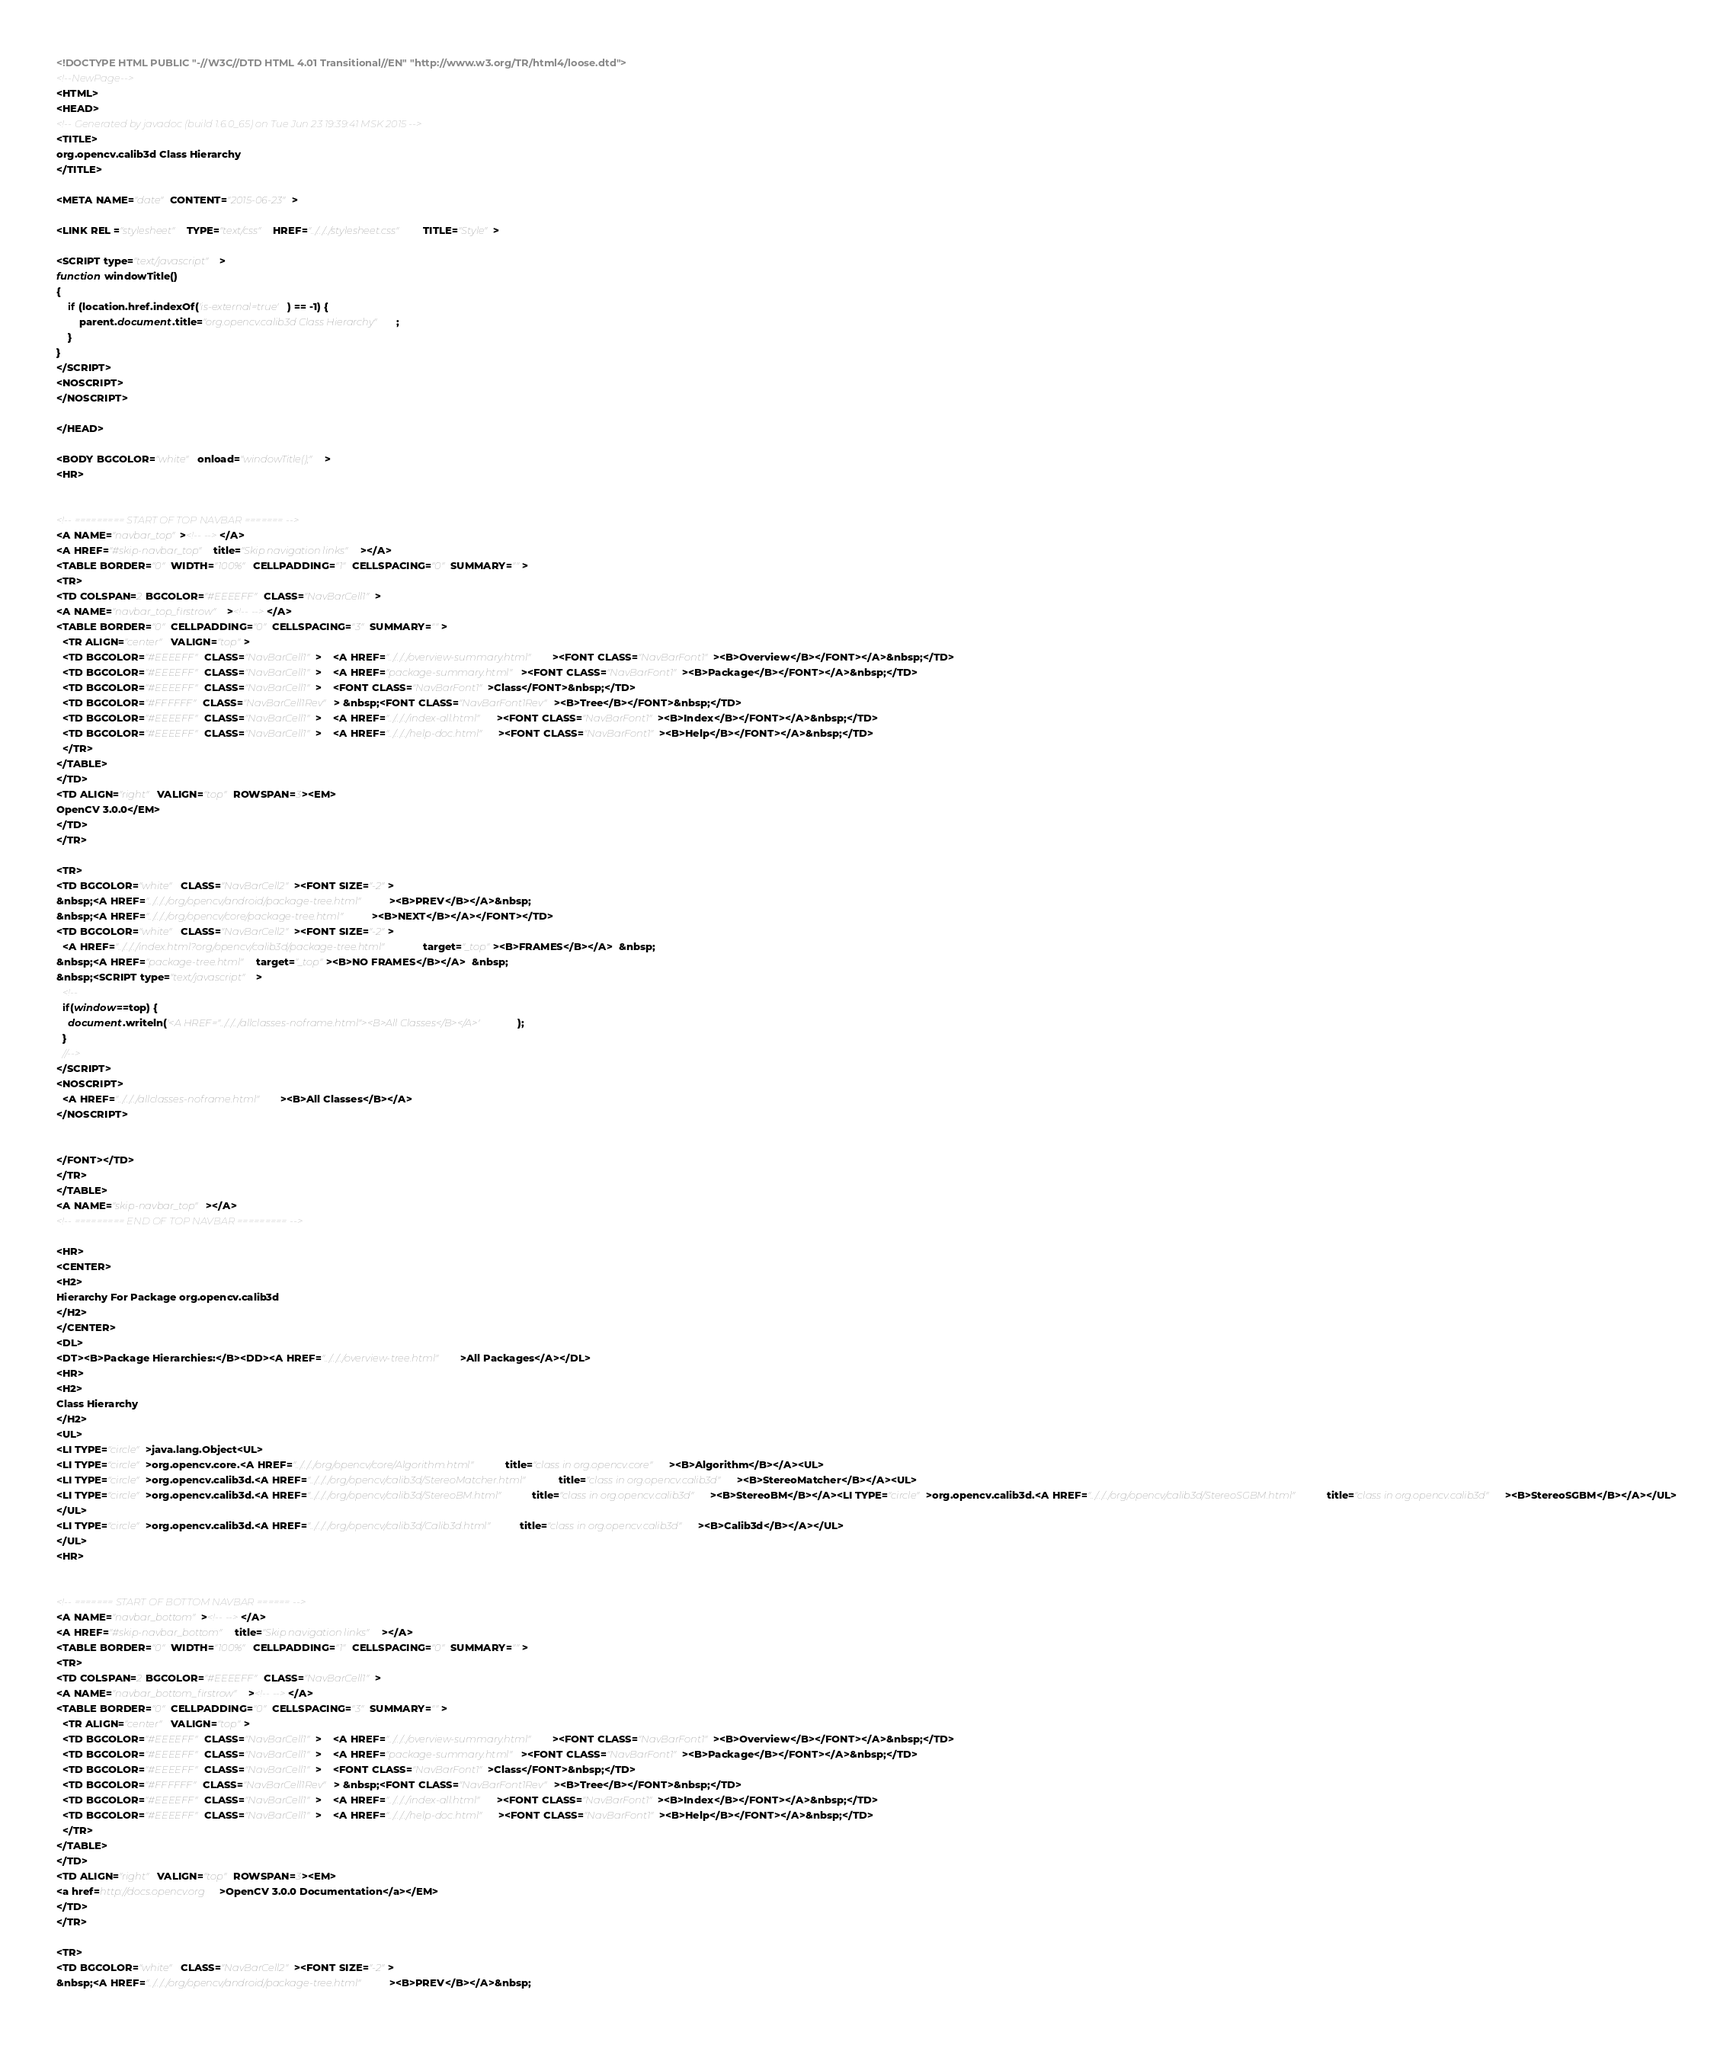Convert code to text. <code><loc_0><loc_0><loc_500><loc_500><_HTML_><!DOCTYPE HTML PUBLIC "-//W3C//DTD HTML 4.01 Transitional//EN" "http://www.w3.org/TR/html4/loose.dtd">
<!--NewPage-->
<HTML>
<HEAD>
<!-- Generated by javadoc (build 1.6.0_65) on Tue Jun 23 19:39:41 MSK 2015 -->
<TITLE>
org.opencv.calib3d Class Hierarchy
</TITLE>

<META NAME="date" CONTENT="2015-06-23">

<LINK REL ="stylesheet" TYPE="text/css" HREF="../../../stylesheet.css" TITLE="Style">

<SCRIPT type="text/javascript">
function windowTitle()
{
    if (location.href.indexOf('is-external=true') == -1) {
        parent.document.title="org.opencv.calib3d Class Hierarchy";
    }
}
</SCRIPT>
<NOSCRIPT>
</NOSCRIPT>

</HEAD>

<BODY BGCOLOR="white" onload="windowTitle();">
<HR>


<!-- ========= START OF TOP NAVBAR ======= -->
<A NAME="navbar_top"><!-- --></A>
<A HREF="#skip-navbar_top" title="Skip navigation links"></A>
<TABLE BORDER="0" WIDTH="100%" CELLPADDING="1" CELLSPACING="0" SUMMARY="">
<TR>
<TD COLSPAN=2 BGCOLOR="#EEEEFF" CLASS="NavBarCell1">
<A NAME="navbar_top_firstrow"><!-- --></A>
<TABLE BORDER="0" CELLPADDING="0" CELLSPACING="3" SUMMARY="">
  <TR ALIGN="center" VALIGN="top">
  <TD BGCOLOR="#EEEEFF" CLASS="NavBarCell1">    <A HREF="../../../overview-summary.html"><FONT CLASS="NavBarFont1"><B>Overview</B></FONT></A>&nbsp;</TD>
  <TD BGCOLOR="#EEEEFF" CLASS="NavBarCell1">    <A HREF="package-summary.html"><FONT CLASS="NavBarFont1"><B>Package</B></FONT></A>&nbsp;</TD>
  <TD BGCOLOR="#EEEEFF" CLASS="NavBarCell1">    <FONT CLASS="NavBarFont1">Class</FONT>&nbsp;</TD>
  <TD BGCOLOR="#FFFFFF" CLASS="NavBarCell1Rev"> &nbsp;<FONT CLASS="NavBarFont1Rev"><B>Tree</B></FONT>&nbsp;</TD>
  <TD BGCOLOR="#EEEEFF" CLASS="NavBarCell1">    <A HREF="../../../index-all.html"><FONT CLASS="NavBarFont1"><B>Index</B></FONT></A>&nbsp;</TD>
  <TD BGCOLOR="#EEEEFF" CLASS="NavBarCell1">    <A HREF="../../../help-doc.html"><FONT CLASS="NavBarFont1"><B>Help</B></FONT></A>&nbsp;</TD>
  </TR>
</TABLE>
</TD>
<TD ALIGN="right" VALIGN="top" ROWSPAN=3><EM>
OpenCV 3.0.0</EM>
</TD>
</TR>

<TR>
<TD BGCOLOR="white" CLASS="NavBarCell2"><FONT SIZE="-2">
&nbsp;<A HREF="../../../org/opencv/android/package-tree.html"><B>PREV</B></A>&nbsp;
&nbsp;<A HREF="../../../org/opencv/core/package-tree.html"><B>NEXT</B></A></FONT></TD>
<TD BGCOLOR="white" CLASS="NavBarCell2"><FONT SIZE="-2">
  <A HREF="../../../index.html?org/opencv/calib3d/package-tree.html" target="_top"><B>FRAMES</B></A>  &nbsp;
&nbsp;<A HREF="package-tree.html" target="_top"><B>NO FRAMES</B></A>  &nbsp;
&nbsp;<SCRIPT type="text/javascript">
  <!--
  if(window==top) {
    document.writeln('<A HREF="../../../allclasses-noframe.html"><B>All Classes</B></A>');
  }
  //-->
</SCRIPT>
<NOSCRIPT>
  <A HREF="../../../allclasses-noframe.html"><B>All Classes</B></A>
</NOSCRIPT>


</FONT></TD>
</TR>
</TABLE>
<A NAME="skip-navbar_top"></A>
<!-- ========= END OF TOP NAVBAR ========= -->

<HR>
<CENTER>
<H2>
Hierarchy For Package org.opencv.calib3d
</H2>
</CENTER>
<DL>
<DT><B>Package Hierarchies:</B><DD><A HREF="../../../overview-tree.html">All Packages</A></DL>
<HR>
<H2>
Class Hierarchy
</H2>
<UL>
<LI TYPE="circle">java.lang.Object<UL>
<LI TYPE="circle">org.opencv.core.<A HREF="../../../org/opencv/core/Algorithm.html" title="class in org.opencv.core"><B>Algorithm</B></A><UL>
<LI TYPE="circle">org.opencv.calib3d.<A HREF="../../../org/opencv/calib3d/StereoMatcher.html" title="class in org.opencv.calib3d"><B>StereoMatcher</B></A><UL>
<LI TYPE="circle">org.opencv.calib3d.<A HREF="../../../org/opencv/calib3d/StereoBM.html" title="class in org.opencv.calib3d"><B>StereoBM</B></A><LI TYPE="circle">org.opencv.calib3d.<A HREF="../../../org/opencv/calib3d/StereoSGBM.html" title="class in org.opencv.calib3d"><B>StereoSGBM</B></A></UL>
</UL>
<LI TYPE="circle">org.opencv.calib3d.<A HREF="../../../org/opencv/calib3d/Calib3d.html" title="class in org.opencv.calib3d"><B>Calib3d</B></A></UL>
</UL>
<HR>


<!-- ======= START OF BOTTOM NAVBAR ====== -->
<A NAME="navbar_bottom"><!-- --></A>
<A HREF="#skip-navbar_bottom" title="Skip navigation links"></A>
<TABLE BORDER="0" WIDTH="100%" CELLPADDING="1" CELLSPACING="0" SUMMARY="">
<TR>
<TD COLSPAN=2 BGCOLOR="#EEEEFF" CLASS="NavBarCell1">
<A NAME="navbar_bottom_firstrow"><!-- --></A>
<TABLE BORDER="0" CELLPADDING="0" CELLSPACING="3" SUMMARY="">
  <TR ALIGN="center" VALIGN="top">
  <TD BGCOLOR="#EEEEFF" CLASS="NavBarCell1">    <A HREF="../../../overview-summary.html"><FONT CLASS="NavBarFont1"><B>Overview</B></FONT></A>&nbsp;</TD>
  <TD BGCOLOR="#EEEEFF" CLASS="NavBarCell1">    <A HREF="package-summary.html"><FONT CLASS="NavBarFont1"><B>Package</B></FONT></A>&nbsp;</TD>
  <TD BGCOLOR="#EEEEFF" CLASS="NavBarCell1">    <FONT CLASS="NavBarFont1">Class</FONT>&nbsp;</TD>
  <TD BGCOLOR="#FFFFFF" CLASS="NavBarCell1Rev"> &nbsp;<FONT CLASS="NavBarFont1Rev"><B>Tree</B></FONT>&nbsp;</TD>
  <TD BGCOLOR="#EEEEFF" CLASS="NavBarCell1">    <A HREF="../../../index-all.html"><FONT CLASS="NavBarFont1"><B>Index</B></FONT></A>&nbsp;</TD>
  <TD BGCOLOR="#EEEEFF" CLASS="NavBarCell1">    <A HREF="../../../help-doc.html"><FONT CLASS="NavBarFont1"><B>Help</B></FONT></A>&nbsp;</TD>
  </TR>
</TABLE>
</TD>
<TD ALIGN="right" VALIGN="top" ROWSPAN=3><EM>
<a href=http://docs.opencv.org>OpenCV 3.0.0 Documentation</a></EM>
</TD>
</TR>

<TR>
<TD BGCOLOR="white" CLASS="NavBarCell2"><FONT SIZE="-2">
&nbsp;<A HREF="../../../org/opencv/android/package-tree.html"><B>PREV</B></A>&nbsp;</code> 